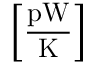<formula> <loc_0><loc_0><loc_500><loc_500>\left [ \frac { p W } { K } \right ]</formula> 